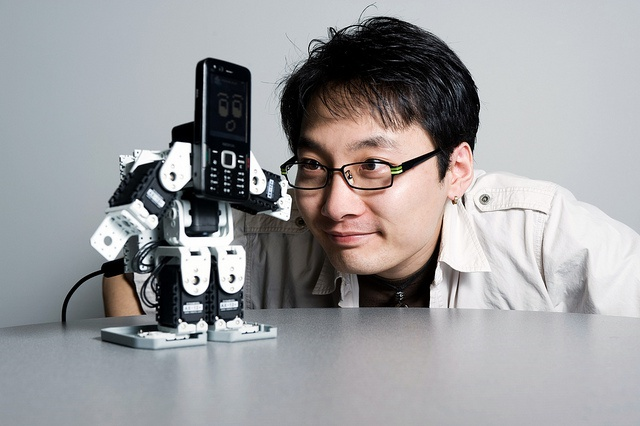Describe the objects in this image and their specific colors. I can see people in darkgray, lightgray, black, gray, and tan tones and cell phone in darkgray, black, gray, and lightgray tones in this image. 